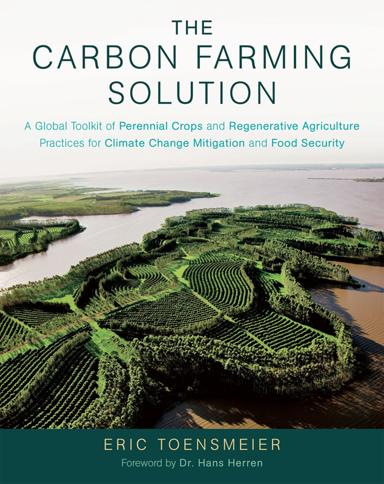What specific agricultural practices mentioned in the book could be tied to the landscapes shown in the cover image? The landscapes on the cover are likely examples of agroforestry and contour farming, both discussed in the book. Agroforestry involves integrating trees and shrubs into crop systems for benefits like shade, soil enrichment, and biodiversity, while contour farming aligns planting with the natural terrain contours to conserve rainwater and reduce soil loss. 